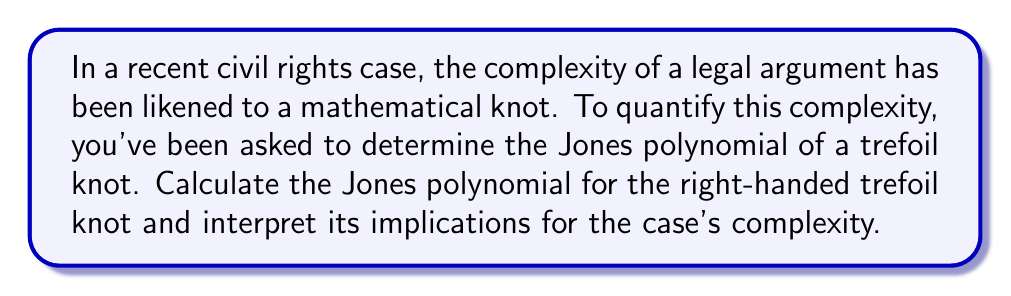What is the answer to this math problem? To determine the Jones polynomial of a right-handed trefoil knot, we'll follow these steps:

1) The Jones polynomial is calculated using the Kauffman bracket polynomial and the writhe of the knot.

2) For a right-handed trefoil knot:
   - It has 3 positive crossings
   - The writhe w = 3

3) Calculate the Kauffman bracket polynomial:
   $$\langle K \rangle = (-A^3)^3 (A^{-1} + A^{-3} - A^{-4})$$

4) Simplify:
   $$\langle K \rangle = -A^9 + A^5 + A$$

5) The Jones polynomial V(t) is related to the Kauffman bracket by:
   $$V_K(t) = (-A^3)^{-w} \langle K \rangle |_{A = t^{-1/4}}$$

6) Substitute w = 3 and the Kauffman bracket:
   $$V_K(t) = (-A^3)^{-3} (-A^9 + A^5 + A)|_{A = t^{-1/4}}$$

7) Simplify:
   $$V_K(t) = -A^{-9} (-A^9 + A^5 + A)|_{A = t^{-1/4}}$$
   $$V_K(t) = (1 - A^{-4} - A^{-8})|_{A = t^{-1/4}}$$

8) Substitute $A = t^{-1/4}$:
   $$V_K(t) = 1 - t - t^2$$

This polynomial indicates a relatively simple knot structure, suggesting that while the legal argument has some complexity, it's not overwhelmingly intricate.
Answer: $V_K(t) = 1 - t - t^2$ 